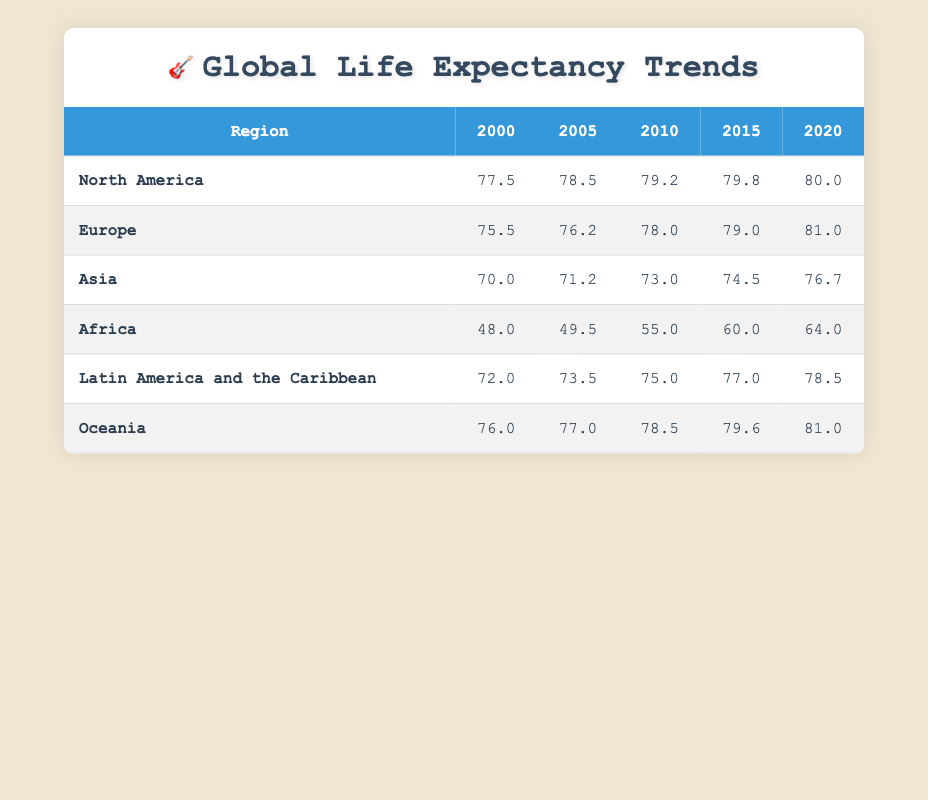What was the life expectancy in Africa in 2020? Looking at the row for Africa under the column for 2020, the life expectancy value is 64.0.
Answer: 64.0 Which region had the largest increase in life expectancy from 2000 to 2020? To find the largest increase, we need to calculate the difference between the values for the years 2000 and 2020 for each region. North America: 80.0 - 77.5 = 2.5, Europe: 81.0 - 75.5 = 5.5, Asia: 76.7 - 70.0 = 6.7, Africa: 64.0 - 48.0 = 16.0, Latin America: 78.5 - 72.0 = 6.5, Oceania: 81.0 - 76.0 = 5.0. Africa had the largest increase of 16.0.
Answer: Africa What was the average life expectancy in Europe for the years 2005, 2010, and 2015? The values for Europe in those years are 76.2 (2005), 78.0 (2010), and 79.0 (2015). To calculate the average, we sum these values: 76.2 + 78.0 + 79.0 = 233.2, then divide by 3. The average is 233.2/3 = 77.73.
Answer: 77.73 Is the life expectancy in Asia greater than that in Latin America in 2010? In 2010, the life expectancy in Asia is 73.0 and in Latin America it is 75.0. Since 73.0 is less than 75.0, the statement is false.
Answer: No Which region had a life expectancy of 72.0 in 2000, and what was its value in 2020? The region with a life expectancy of 72.0 in 2000 is Latin America and the Caribbean. In 2020, its life expectancy increased to 78.5.
Answer: Latin America and the Caribbean: 78.5 